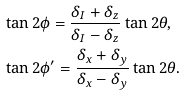<formula> <loc_0><loc_0><loc_500><loc_500>& \tan 2 \phi = \frac { \delta _ { I } + \delta _ { z } } { \delta _ { I } - \delta _ { z } } \tan 2 \theta , \\ & \tan 2 \phi ^ { \prime } = \frac { \delta _ { x } + \delta _ { y } } { \delta _ { x } - \delta _ { y } } \tan 2 \theta .</formula> 